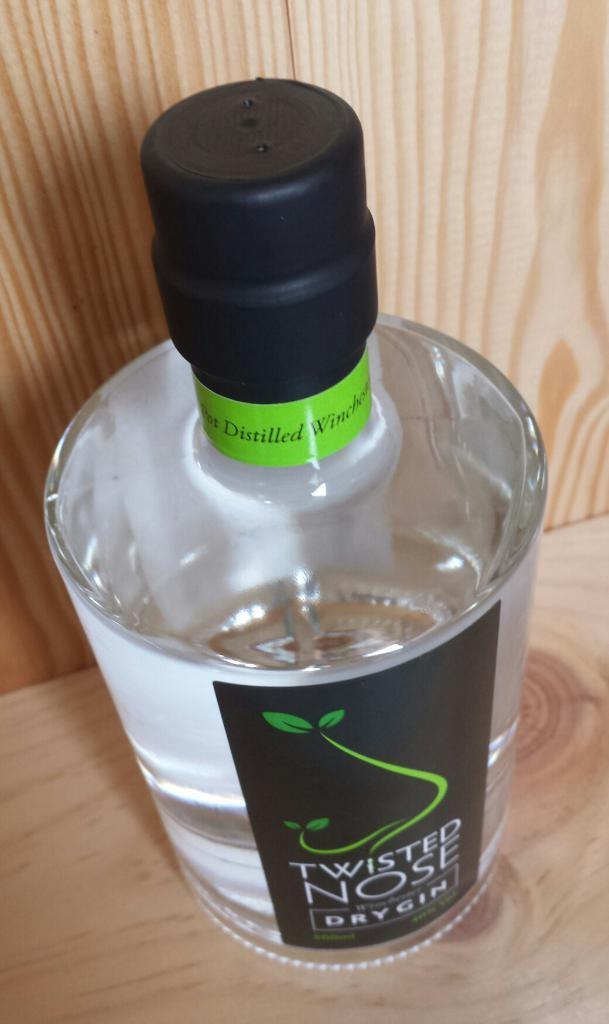<image>
Create a compact narrative representing the image presented. A label with the brand Twisted Nose is on a clear bottle. 